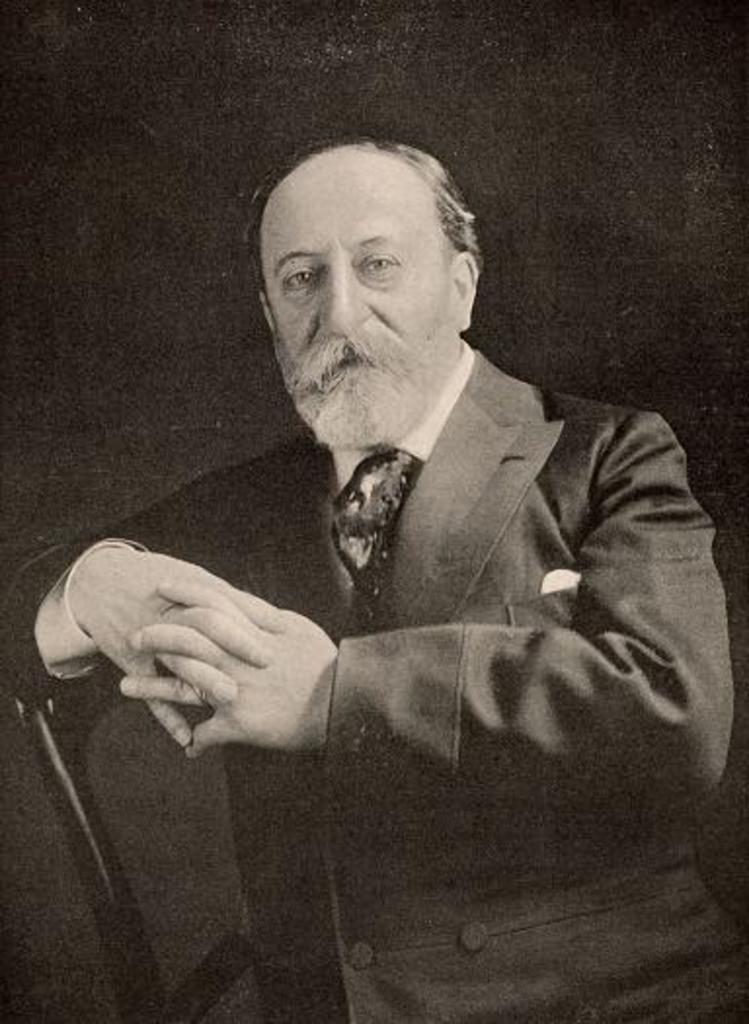What is the color scheme of the image? The image is black and white. Can you describe the person in the image? There is a person in the image, and they are wearing a suit. What is the person doing in the image? The person is sitting in a chair. What type of toothpaste is the person using in the image? There is no toothpaste present in the image. What scent can be detected from the person in the image? The image is black and white, so it is not possible to determine any scents. 